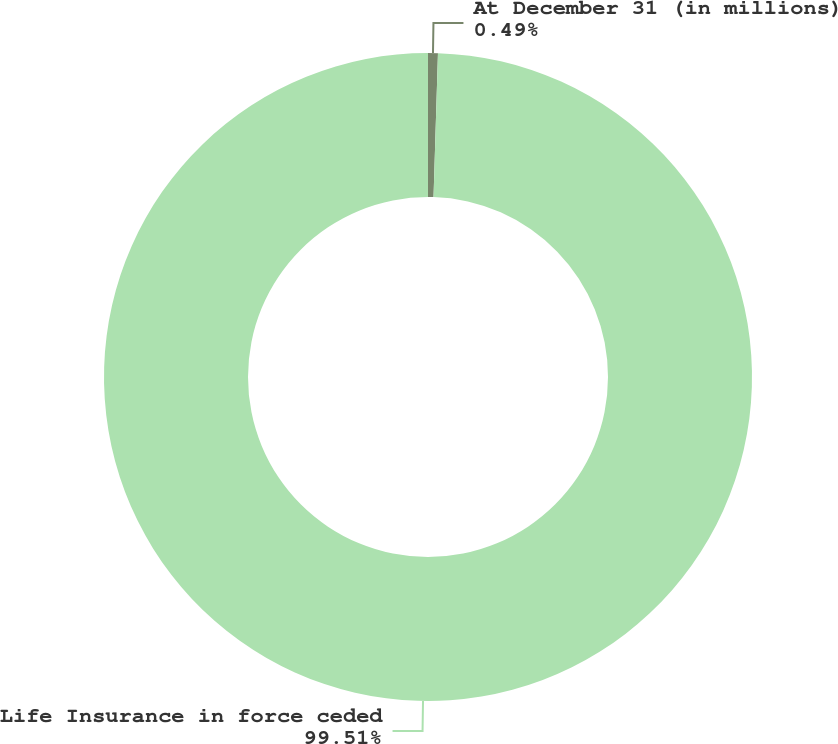Convert chart. <chart><loc_0><loc_0><loc_500><loc_500><pie_chart><fcel>At December 31 (in millions)<fcel>Life Insurance in force ceded<nl><fcel>0.49%<fcel>99.51%<nl></chart> 